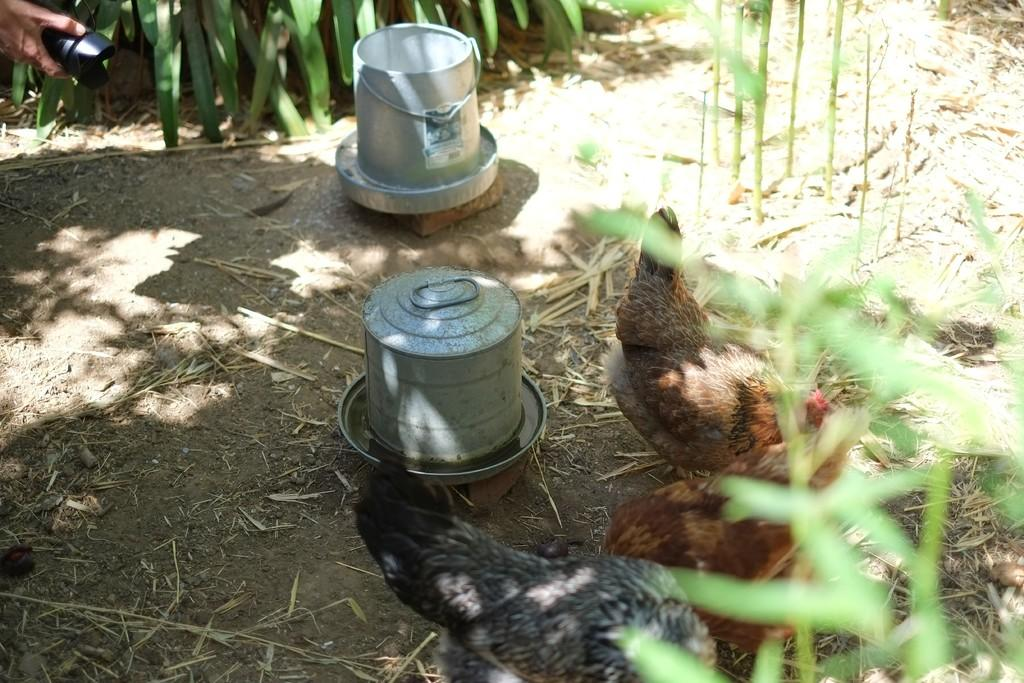How many containers can be seen in the image? There are two containers in the image. What animals are present on the ground in the image? There are hens on the ground in the image. What type of vegetation is visible in the image? There are plants visible in the image. Where is the human hand with a black object located in the image? The human hand with a black object is present in the left side top corner of the image. What type of nut is being used to measure the wealth of the hens in the image? There is no nut present in the image, nor is there any indication of measuring the wealth of the hens. Can you see the ocean in the image? No, the ocean is not visible in the image. 